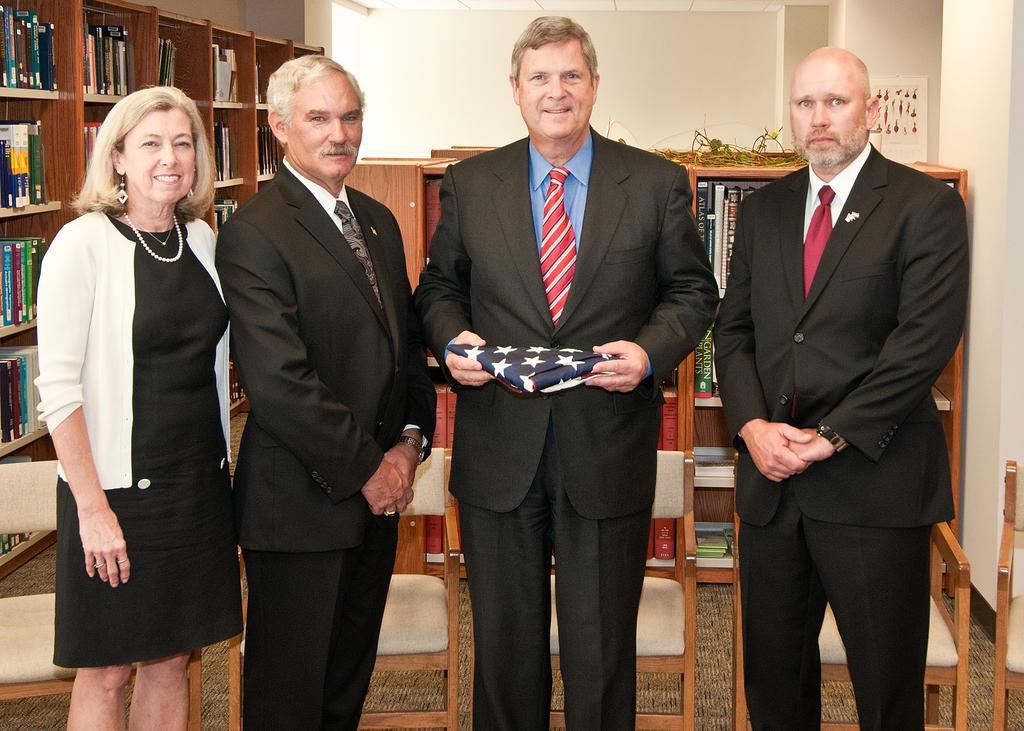Could you give a brief overview of what you see in this image? There are four person standing. One person is holding something in the hand. In the back there is a cupboard with books. In the background there is a wall. Also there are chairs. 